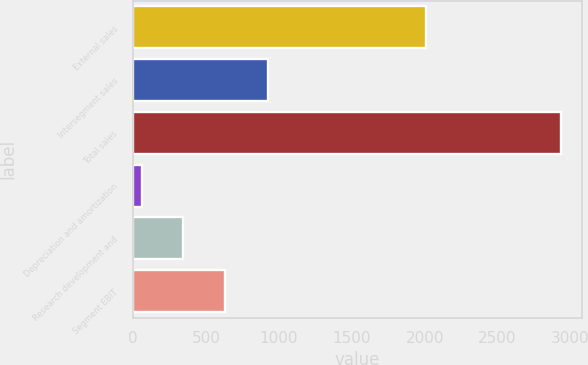Convert chart. <chart><loc_0><loc_0><loc_500><loc_500><bar_chart><fcel>External sales<fcel>Intersegment sales<fcel>Total sales<fcel>Depreciation and amortization<fcel>Research development and<fcel>Segment EBIT<nl><fcel>2007<fcel>925<fcel>2932<fcel>59<fcel>346.3<fcel>633.6<nl></chart> 